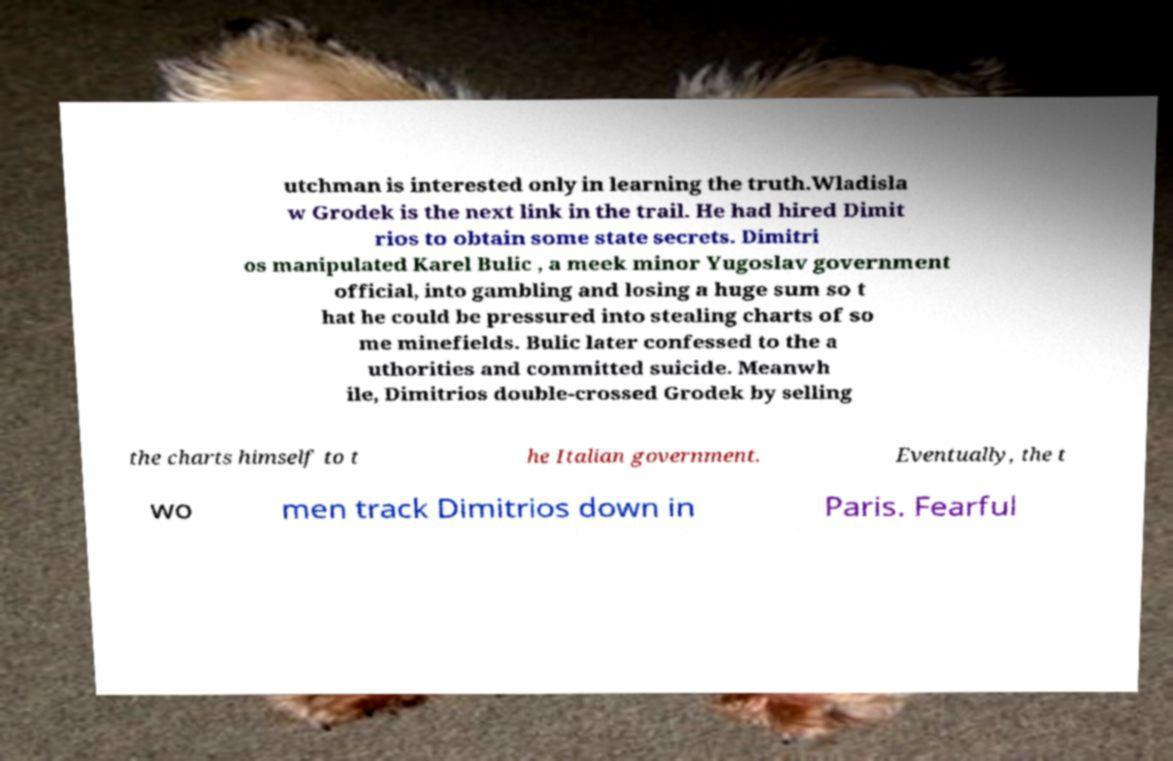Could you extract and type out the text from this image? utchman is interested only in learning the truth.Wladisla w Grodek is the next link in the trail. He had hired Dimit rios to obtain some state secrets. Dimitri os manipulated Karel Bulic , a meek minor Yugoslav government official, into gambling and losing a huge sum so t hat he could be pressured into stealing charts of so me minefields. Bulic later confessed to the a uthorities and committed suicide. Meanwh ile, Dimitrios double-crossed Grodek by selling the charts himself to t he Italian government. Eventually, the t wo men track Dimitrios down in Paris. Fearful 